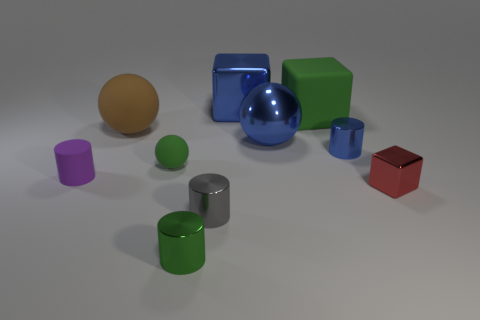Does the rubber block have the same color as the small rubber sphere?
Offer a very short reply. Yes. Are there any other things that have the same size as the red thing?
Your answer should be very brief. Yes. There is a green metallic object that is the same size as the gray metallic thing; what shape is it?
Keep it short and to the point. Cylinder. How many objects are red metal objects or objects that are in front of the tiny red shiny block?
Your answer should be very brief. 3. Do the big thing that is on the right side of the metal ball and the tiny green object that is in front of the small red shiny cube have the same material?
Your answer should be very brief. No. What shape is the small metal thing that is the same color as the large shiny cube?
Ensure brevity in your answer.  Cylinder. How many brown things are either metal cubes or matte things?
Provide a short and direct response. 1. The green block is what size?
Your response must be concise. Large. Is the number of tiny green objects on the left side of the green cylinder greater than the number of green metallic cylinders?
Keep it short and to the point. No. There is a blue metal sphere; what number of shiny cylinders are right of it?
Make the answer very short. 1. 